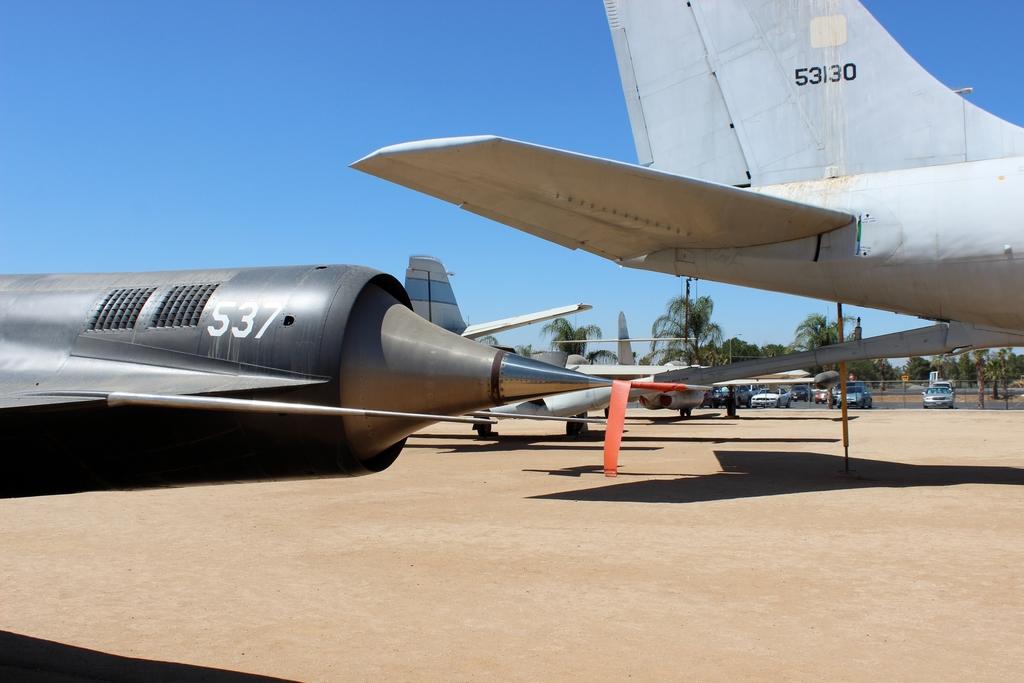What number is on the black plane?
Keep it short and to the point. 537. What number is the gray plane?
Your answer should be very brief. 53130. 